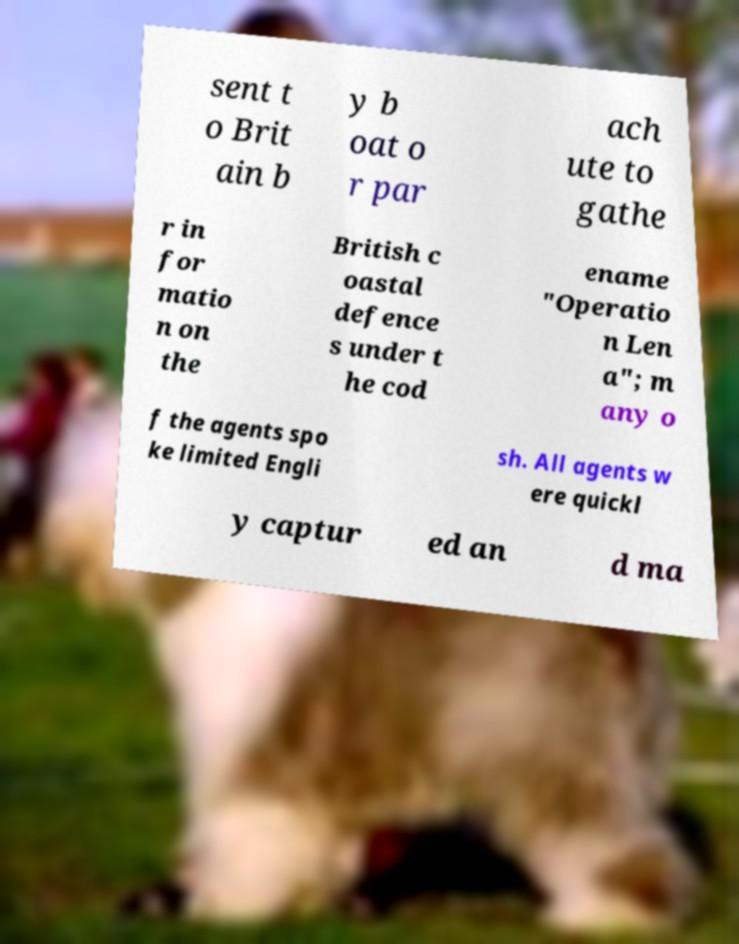What messages or text are displayed in this image? I need them in a readable, typed format. sent t o Brit ain b y b oat o r par ach ute to gathe r in for matio n on the British c oastal defence s under t he cod ename "Operatio n Len a"; m any o f the agents spo ke limited Engli sh. All agents w ere quickl y captur ed an d ma 